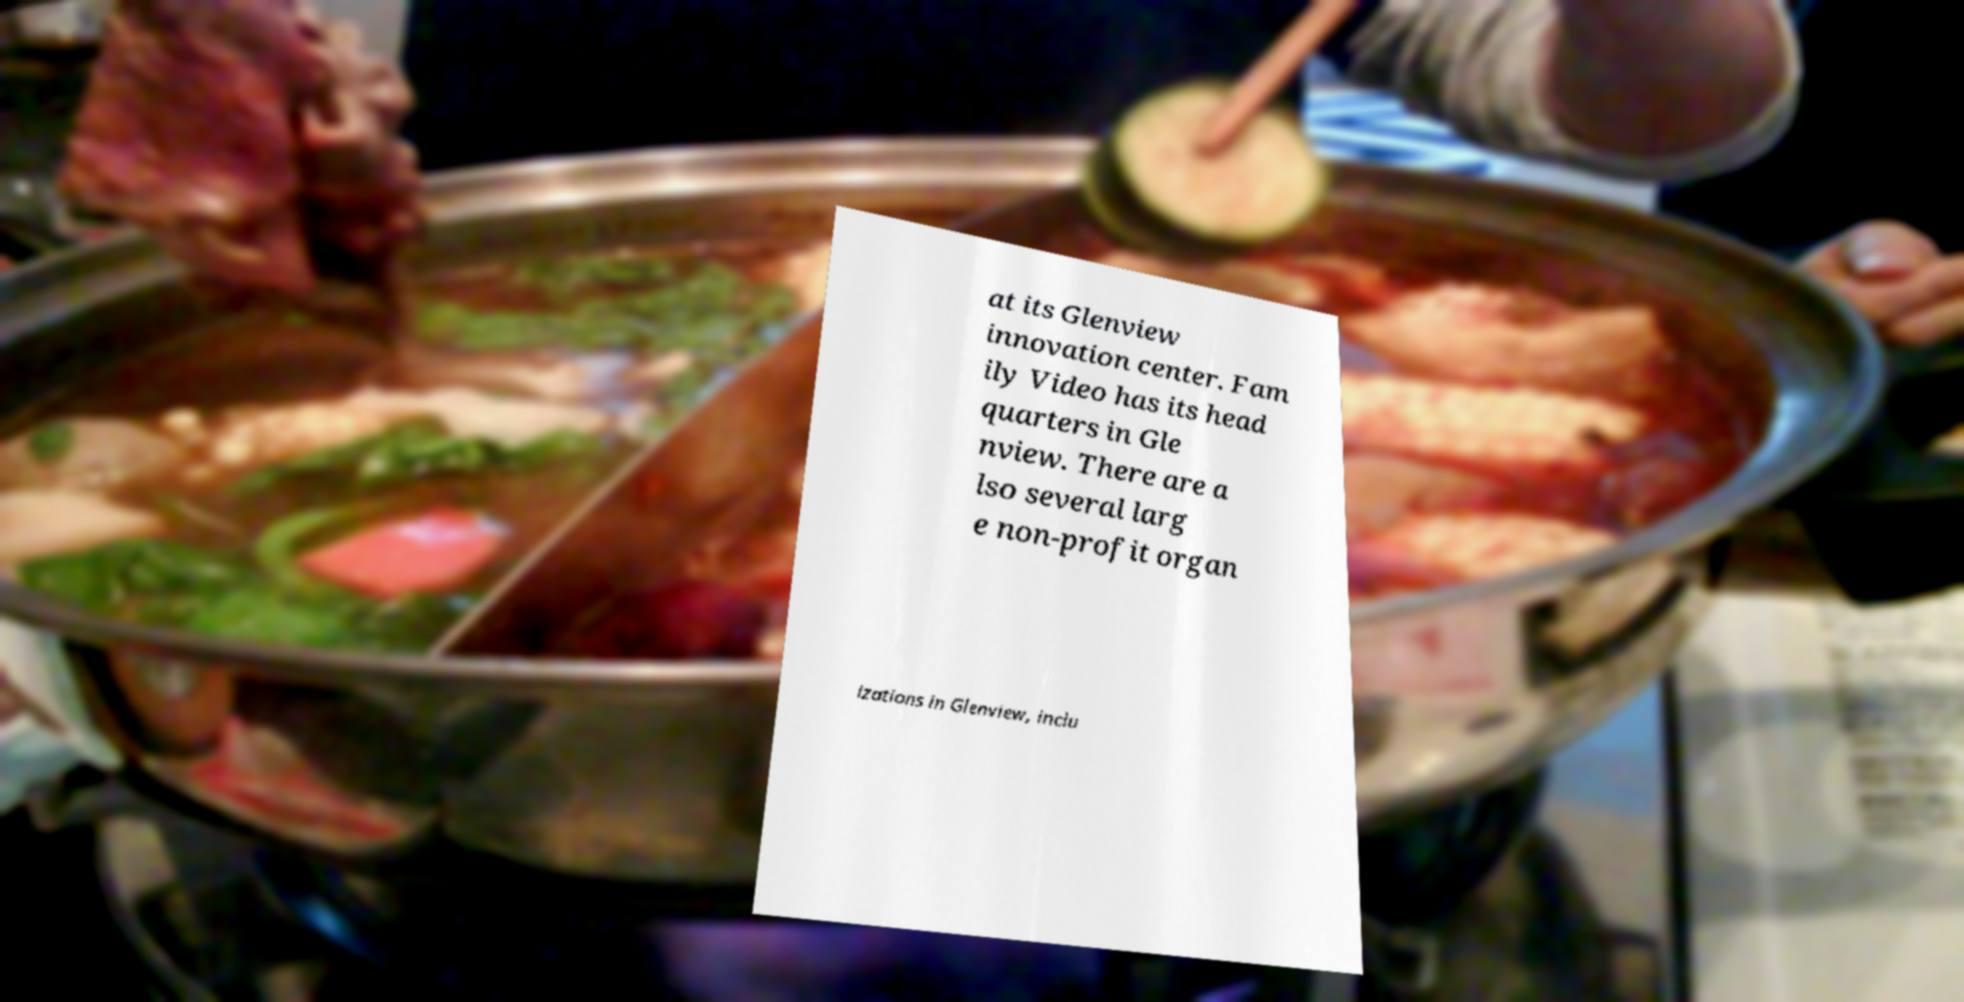I need the written content from this picture converted into text. Can you do that? at its Glenview innovation center. Fam ily Video has its head quarters in Gle nview. There are a lso several larg e non-profit organ izations in Glenview, inclu 